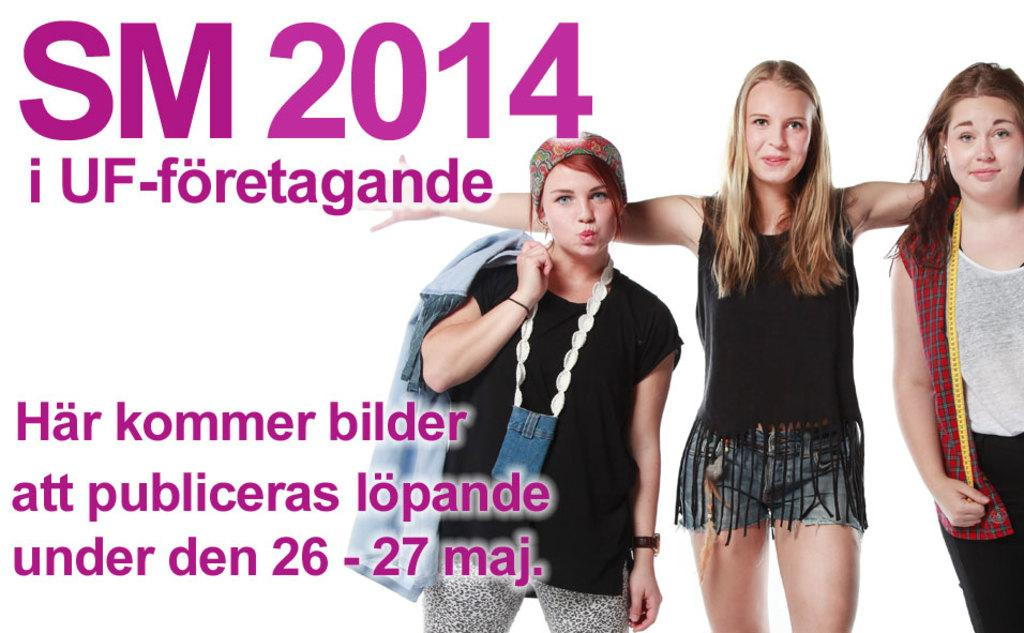What can be seen on the poster in the image? The poster has an image and pink color texts. How many women are in the image? There are three women in the image. What are the women doing in the image? The women are smiling in the image. What color is the background of the image? The background of the image is white in color. Can you tell me what request the women are making in the image? There is no indication in the image that the women are making any requests. How many trucks can be seen in the image? There are no trucks present in the image. 